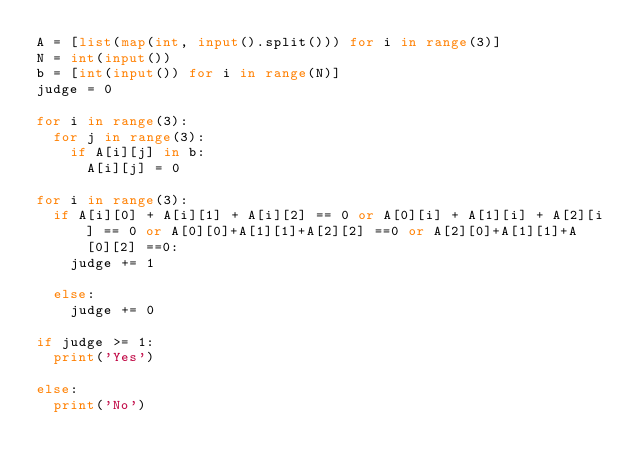Convert code to text. <code><loc_0><loc_0><loc_500><loc_500><_Python_>A = [list(map(int, input().split())) for i in range(3)]
N = int(input())
b = [int(input()) for i in range(N)]
judge = 0

for i in range(3):
  for j in range(3):
    if A[i][j] in b:
      A[i][j] = 0
  
for i in range(3):
  if A[i][0] + A[i][1] + A[i][2] == 0 or A[0][i] + A[1][i] + A[2][i] == 0 or A[0][0]+A[1][1]+A[2][2] ==0 or A[2][0]+A[1][1]+A[0][2] ==0:
    judge += 1
  
  else:
    judge += 0
    
if judge >= 1:
  print('Yes')
  
else:
  print('No')</code> 